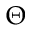<formula> <loc_0><loc_0><loc_500><loc_500>\Theta</formula> 